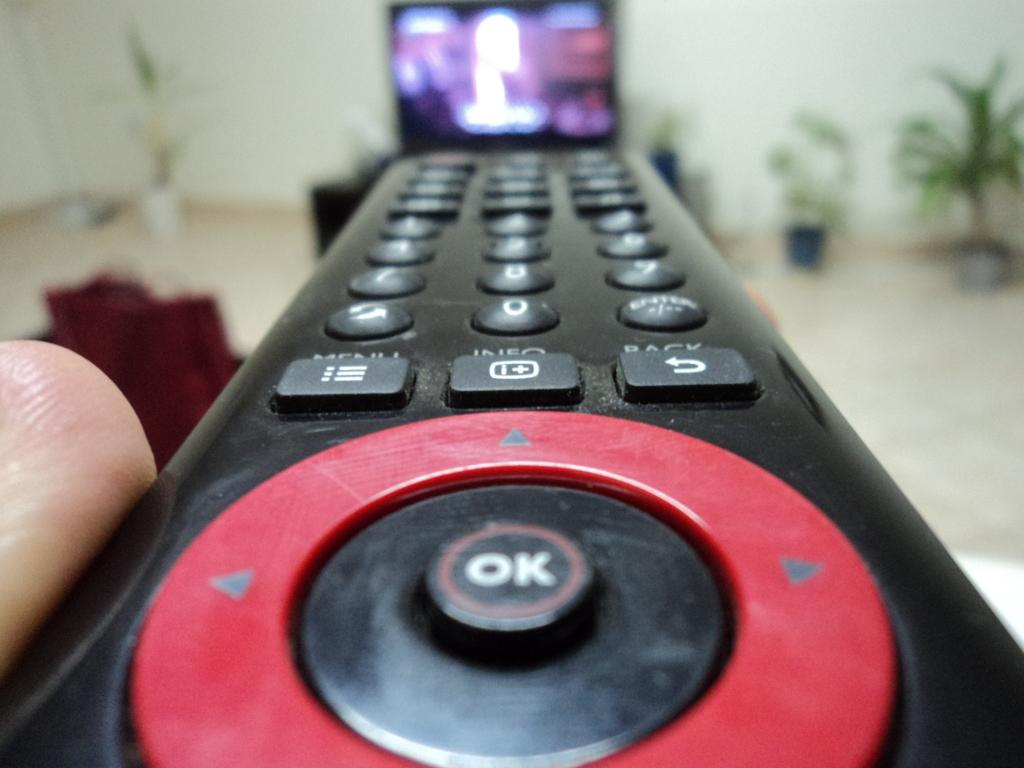Provide a one-sentence caption for the provided image. A close up image of a remote control with a red circle on it surrounding an "OK" button. 